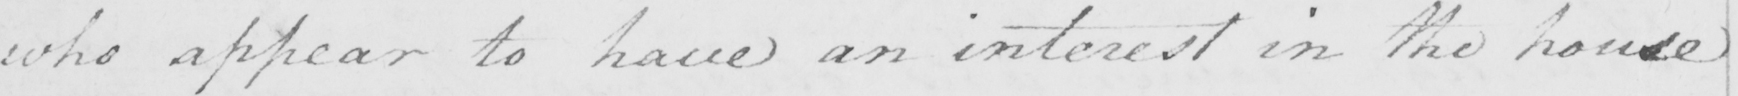Can you tell me what this handwritten text says? who appear to have an interest in the house 